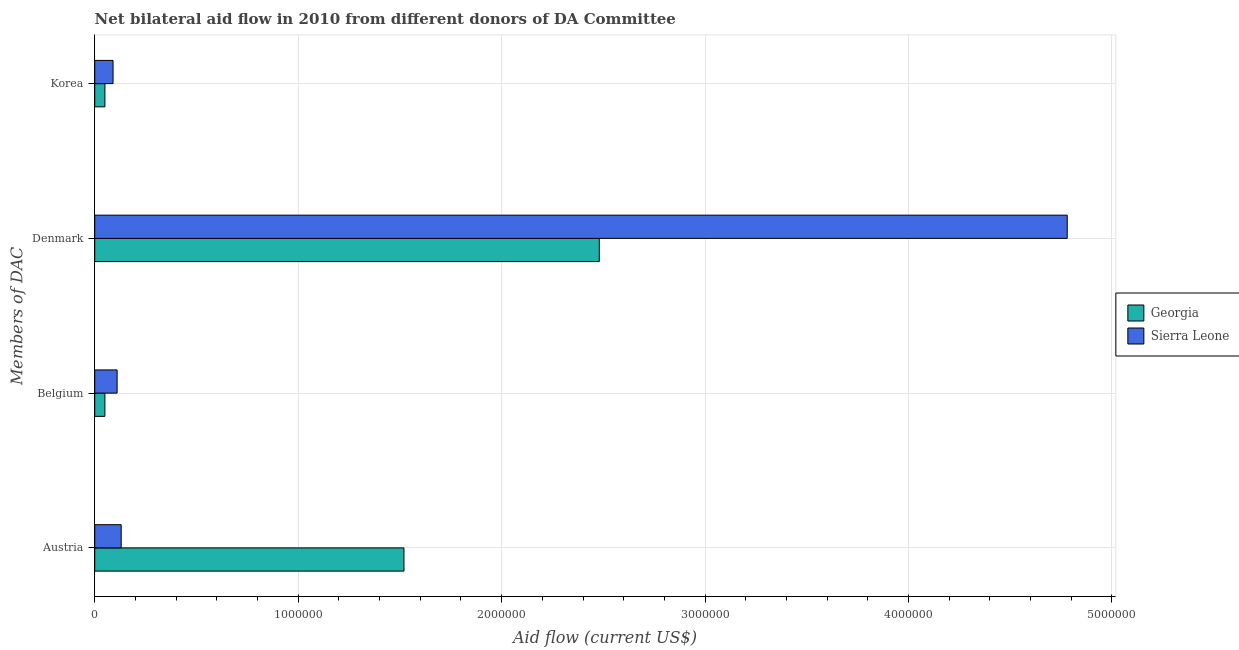How many different coloured bars are there?
Offer a very short reply. 2. Are the number of bars per tick equal to the number of legend labels?
Offer a very short reply. Yes. Are the number of bars on each tick of the Y-axis equal?
Give a very brief answer. Yes. How many bars are there on the 3rd tick from the bottom?
Offer a very short reply. 2. What is the amount of aid given by korea in Georgia?
Provide a succinct answer. 5.00e+04. Across all countries, what is the maximum amount of aid given by austria?
Offer a terse response. 1.52e+06. Across all countries, what is the minimum amount of aid given by austria?
Offer a very short reply. 1.30e+05. In which country was the amount of aid given by belgium maximum?
Your response must be concise. Sierra Leone. In which country was the amount of aid given by belgium minimum?
Your answer should be very brief. Georgia. What is the total amount of aid given by belgium in the graph?
Give a very brief answer. 1.60e+05. What is the difference between the amount of aid given by denmark in Georgia and that in Sierra Leone?
Offer a terse response. -2.30e+06. What is the difference between the amount of aid given by austria in Sierra Leone and the amount of aid given by denmark in Georgia?
Give a very brief answer. -2.35e+06. What is the average amount of aid given by korea per country?
Provide a succinct answer. 7.00e+04. What is the difference between the amount of aid given by denmark and amount of aid given by belgium in Georgia?
Your answer should be very brief. 2.43e+06. In how many countries, is the amount of aid given by denmark greater than 4600000 US$?
Provide a short and direct response. 1. What is the ratio of the amount of aid given by denmark in Georgia to that in Sierra Leone?
Your response must be concise. 0.52. What is the difference between the highest and the second highest amount of aid given by denmark?
Your answer should be very brief. 2.30e+06. What is the difference between the highest and the lowest amount of aid given by korea?
Your answer should be very brief. 4.00e+04. Is the sum of the amount of aid given by korea in Sierra Leone and Georgia greater than the maximum amount of aid given by denmark across all countries?
Keep it short and to the point. No. Is it the case that in every country, the sum of the amount of aid given by korea and amount of aid given by denmark is greater than the sum of amount of aid given by belgium and amount of aid given by austria?
Provide a succinct answer. Yes. What does the 1st bar from the top in Austria represents?
Offer a very short reply. Sierra Leone. What does the 2nd bar from the bottom in Austria represents?
Ensure brevity in your answer.  Sierra Leone. Is it the case that in every country, the sum of the amount of aid given by austria and amount of aid given by belgium is greater than the amount of aid given by denmark?
Provide a succinct answer. No. Are all the bars in the graph horizontal?
Your answer should be very brief. Yes. Does the graph contain any zero values?
Provide a short and direct response. No. Where does the legend appear in the graph?
Keep it short and to the point. Center right. What is the title of the graph?
Ensure brevity in your answer.  Net bilateral aid flow in 2010 from different donors of DA Committee. Does "Cyprus" appear as one of the legend labels in the graph?
Offer a very short reply. No. What is the label or title of the Y-axis?
Your response must be concise. Members of DAC. What is the Aid flow (current US$) of Georgia in Austria?
Ensure brevity in your answer.  1.52e+06. What is the Aid flow (current US$) of Sierra Leone in Austria?
Provide a short and direct response. 1.30e+05. What is the Aid flow (current US$) of Sierra Leone in Belgium?
Make the answer very short. 1.10e+05. What is the Aid flow (current US$) of Georgia in Denmark?
Provide a succinct answer. 2.48e+06. What is the Aid flow (current US$) in Sierra Leone in Denmark?
Your answer should be compact. 4.78e+06. Across all Members of DAC, what is the maximum Aid flow (current US$) of Georgia?
Provide a succinct answer. 2.48e+06. Across all Members of DAC, what is the maximum Aid flow (current US$) in Sierra Leone?
Keep it short and to the point. 4.78e+06. Across all Members of DAC, what is the minimum Aid flow (current US$) of Sierra Leone?
Provide a short and direct response. 9.00e+04. What is the total Aid flow (current US$) in Georgia in the graph?
Your answer should be very brief. 4.10e+06. What is the total Aid flow (current US$) of Sierra Leone in the graph?
Provide a succinct answer. 5.11e+06. What is the difference between the Aid flow (current US$) in Georgia in Austria and that in Belgium?
Offer a very short reply. 1.47e+06. What is the difference between the Aid flow (current US$) in Sierra Leone in Austria and that in Belgium?
Keep it short and to the point. 2.00e+04. What is the difference between the Aid flow (current US$) of Georgia in Austria and that in Denmark?
Offer a terse response. -9.60e+05. What is the difference between the Aid flow (current US$) of Sierra Leone in Austria and that in Denmark?
Offer a terse response. -4.65e+06. What is the difference between the Aid flow (current US$) in Georgia in Austria and that in Korea?
Your answer should be compact. 1.47e+06. What is the difference between the Aid flow (current US$) in Georgia in Belgium and that in Denmark?
Keep it short and to the point. -2.43e+06. What is the difference between the Aid flow (current US$) in Sierra Leone in Belgium and that in Denmark?
Make the answer very short. -4.67e+06. What is the difference between the Aid flow (current US$) in Georgia in Belgium and that in Korea?
Your response must be concise. 0. What is the difference between the Aid flow (current US$) in Georgia in Denmark and that in Korea?
Make the answer very short. 2.43e+06. What is the difference between the Aid flow (current US$) of Sierra Leone in Denmark and that in Korea?
Offer a terse response. 4.69e+06. What is the difference between the Aid flow (current US$) in Georgia in Austria and the Aid flow (current US$) in Sierra Leone in Belgium?
Make the answer very short. 1.41e+06. What is the difference between the Aid flow (current US$) of Georgia in Austria and the Aid flow (current US$) of Sierra Leone in Denmark?
Ensure brevity in your answer.  -3.26e+06. What is the difference between the Aid flow (current US$) of Georgia in Austria and the Aid flow (current US$) of Sierra Leone in Korea?
Ensure brevity in your answer.  1.43e+06. What is the difference between the Aid flow (current US$) of Georgia in Belgium and the Aid flow (current US$) of Sierra Leone in Denmark?
Give a very brief answer. -4.73e+06. What is the difference between the Aid flow (current US$) of Georgia in Denmark and the Aid flow (current US$) of Sierra Leone in Korea?
Your answer should be compact. 2.39e+06. What is the average Aid flow (current US$) of Georgia per Members of DAC?
Ensure brevity in your answer.  1.02e+06. What is the average Aid flow (current US$) in Sierra Leone per Members of DAC?
Provide a succinct answer. 1.28e+06. What is the difference between the Aid flow (current US$) in Georgia and Aid flow (current US$) in Sierra Leone in Austria?
Ensure brevity in your answer.  1.39e+06. What is the difference between the Aid flow (current US$) in Georgia and Aid flow (current US$) in Sierra Leone in Denmark?
Offer a very short reply. -2.30e+06. What is the ratio of the Aid flow (current US$) of Georgia in Austria to that in Belgium?
Offer a very short reply. 30.4. What is the ratio of the Aid flow (current US$) of Sierra Leone in Austria to that in Belgium?
Make the answer very short. 1.18. What is the ratio of the Aid flow (current US$) in Georgia in Austria to that in Denmark?
Give a very brief answer. 0.61. What is the ratio of the Aid flow (current US$) of Sierra Leone in Austria to that in Denmark?
Keep it short and to the point. 0.03. What is the ratio of the Aid flow (current US$) in Georgia in Austria to that in Korea?
Make the answer very short. 30.4. What is the ratio of the Aid flow (current US$) in Sierra Leone in Austria to that in Korea?
Your answer should be compact. 1.44. What is the ratio of the Aid flow (current US$) of Georgia in Belgium to that in Denmark?
Offer a very short reply. 0.02. What is the ratio of the Aid flow (current US$) of Sierra Leone in Belgium to that in Denmark?
Ensure brevity in your answer.  0.02. What is the ratio of the Aid flow (current US$) of Sierra Leone in Belgium to that in Korea?
Give a very brief answer. 1.22. What is the ratio of the Aid flow (current US$) of Georgia in Denmark to that in Korea?
Offer a terse response. 49.6. What is the ratio of the Aid flow (current US$) of Sierra Leone in Denmark to that in Korea?
Keep it short and to the point. 53.11. What is the difference between the highest and the second highest Aid flow (current US$) of Georgia?
Keep it short and to the point. 9.60e+05. What is the difference between the highest and the second highest Aid flow (current US$) of Sierra Leone?
Ensure brevity in your answer.  4.65e+06. What is the difference between the highest and the lowest Aid flow (current US$) in Georgia?
Make the answer very short. 2.43e+06. What is the difference between the highest and the lowest Aid flow (current US$) in Sierra Leone?
Keep it short and to the point. 4.69e+06. 